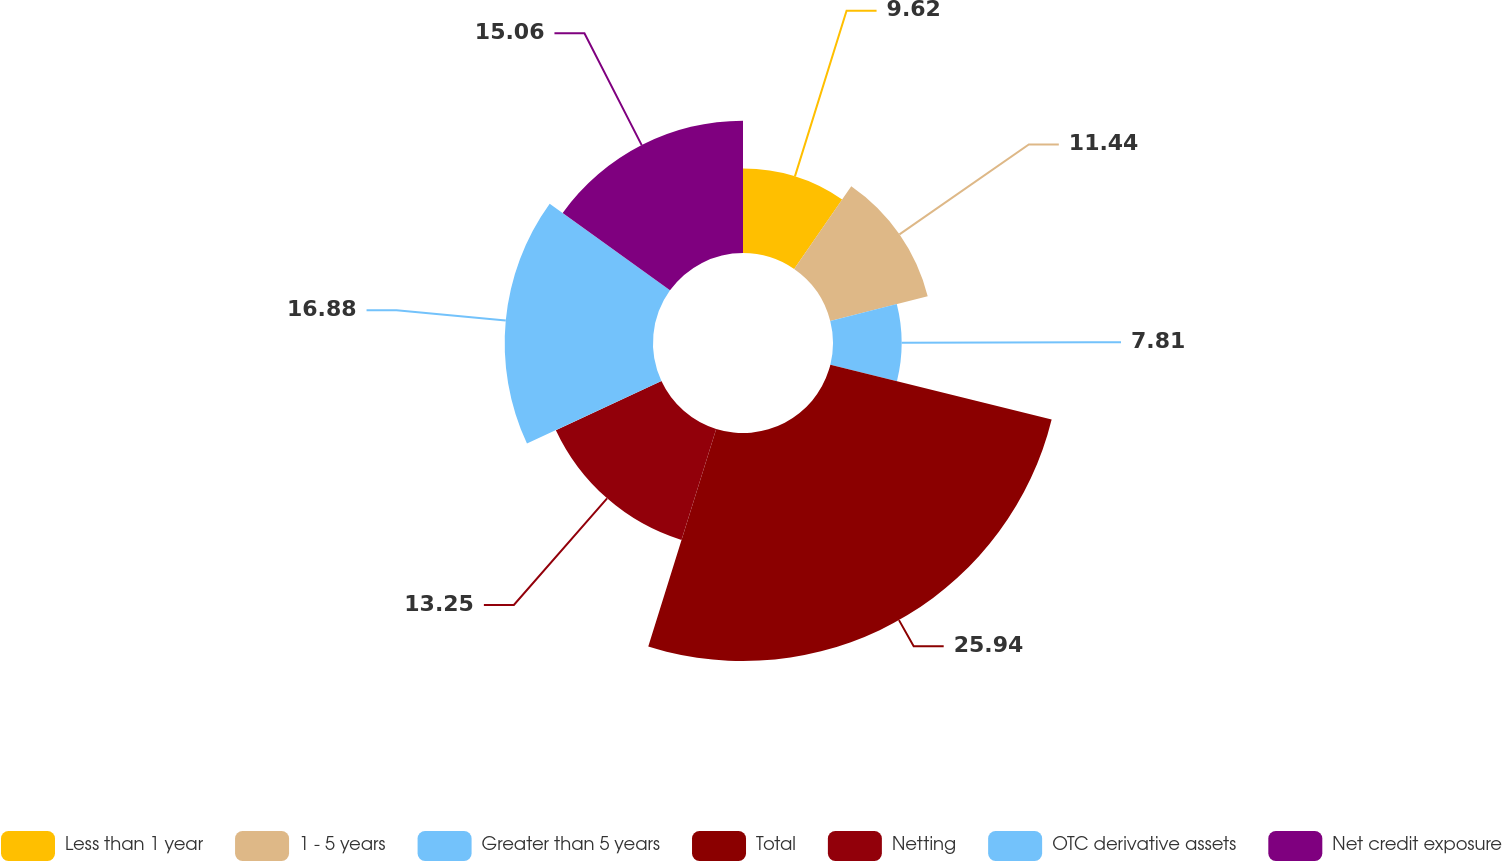<chart> <loc_0><loc_0><loc_500><loc_500><pie_chart><fcel>Less than 1 year<fcel>1 - 5 years<fcel>Greater than 5 years<fcel>Total<fcel>Netting<fcel>OTC derivative assets<fcel>Net credit exposure<nl><fcel>9.62%<fcel>11.44%<fcel>7.81%<fcel>25.95%<fcel>13.25%<fcel>16.88%<fcel>15.06%<nl></chart> 